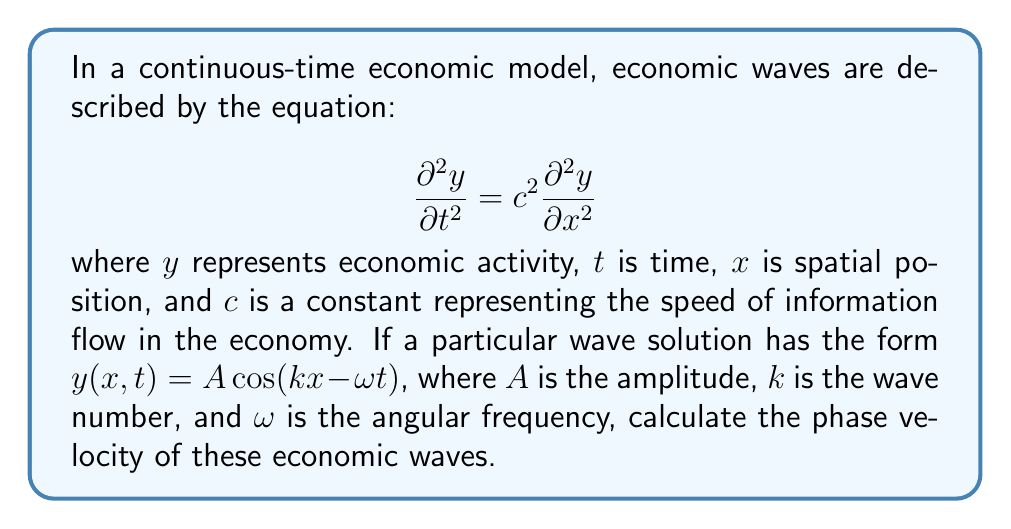Give your solution to this math problem. To solve this problem, we'll follow these steps:

1) The phase velocity $v_p$ is defined as the speed at which a particular phase of the wave propagates. It's given by the formula:

   $$v_p = \frac{\omega}{k}$$

2) To find the relationship between $\omega$ and $k$, we need to substitute the wave solution into the wave equation:

   $$y(x,t) = A \cos(kx - \omega t)$$

3) Calculate the partial derivatives:

   $$\frac{\partial y}{\partial t} = A\omega \sin(kx - \omega t)$$
   $$\frac{\partial^2 y}{\partial t^2} = -A\omega^2 \cos(kx - \omega t)$$
   $$\frac{\partial y}{\partial x} = -Ak \sin(kx - \omega t)$$
   $$\frac{\partial^2 y}{\partial x^2} = -Ak^2 \cos(kx - \omega t)$$

4) Substitute these into the wave equation:

   $$-A\omega^2 \cos(kx - \omega t) = c^2(-Ak^2 \cos(kx - \omega t))$$

5) The $A \cos(kx - \omega t)$ terms cancel out, leaving:

   $$\omega^2 = c^2k^2$$

6) Solve for $\omega$:

   $$\omega = ck$$

7) Now we can calculate the phase velocity:

   $$v_p = \frac{\omega}{k} = \frac{ck}{k} = c$$

Therefore, the phase velocity of the economic waves is equal to the constant $c$, which represents the speed of information flow in the economy.
Answer: $v_p = c$ 